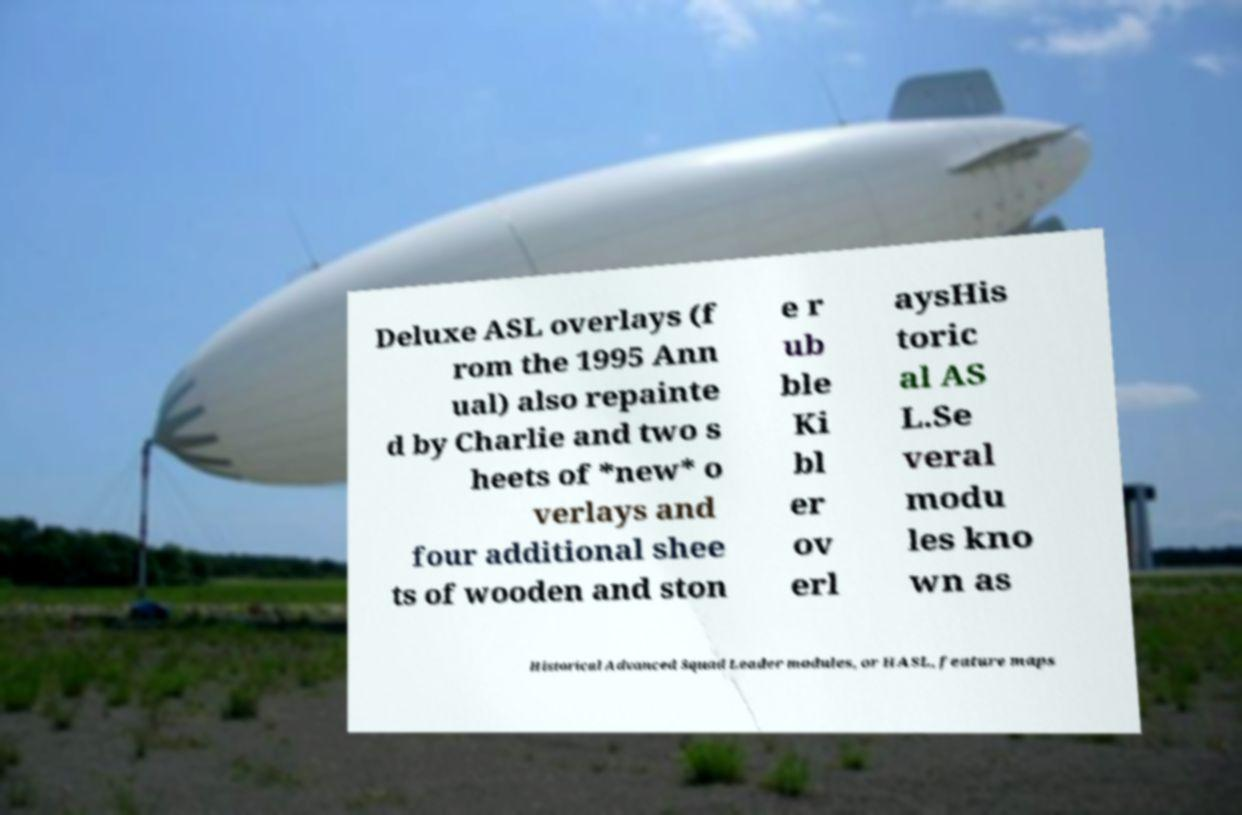What messages or text are displayed in this image? I need them in a readable, typed format. Deluxe ASL overlays (f rom the 1995 Ann ual) also repainte d by Charlie and two s heets of *new* o verlays and four additional shee ts of wooden and ston e r ub ble Ki bl er ov erl aysHis toric al AS L.Se veral modu les kno wn as Historical Advanced Squad Leader modules, or HASL, feature maps 